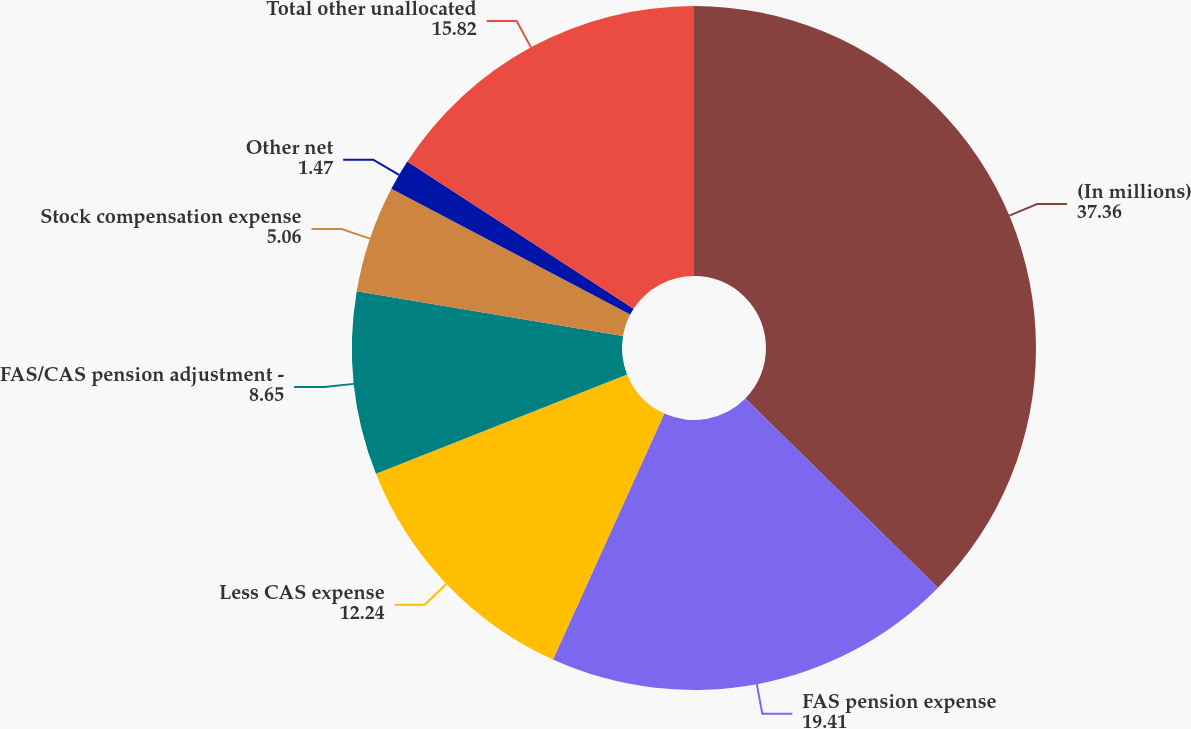<chart> <loc_0><loc_0><loc_500><loc_500><pie_chart><fcel>(In millions)<fcel>FAS pension expense<fcel>Less CAS expense<fcel>FAS/CAS pension adjustment -<fcel>Stock compensation expense<fcel>Other net<fcel>Total other unallocated<nl><fcel>37.36%<fcel>19.41%<fcel>12.24%<fcel>8.65%<fcel>5.06%<fcel>1.47%<fcel>15.82%<nl></chart> 